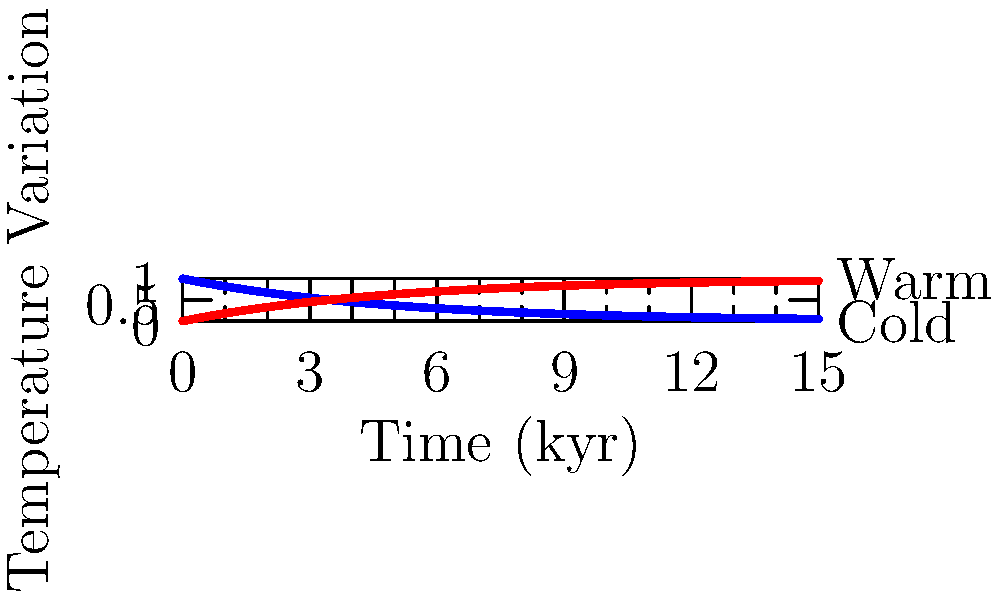In the context of using capacitor charge/discharge curves to model prehistoric climate cycles, what does the blue curve in the graph represent, and how might it relate to a specific prehistoric climate event? To answer this question, let's analyze the graph step-by-step:

1. The graph shows two curves: a blue curve (discharge) and a red curve (charge).

2. The y-axis represents temperature variation, with "Warm" at the top and "Cold" at the bottom.

3. The x-axis represents time in kiloyears (kyr).

4. The blue curve follows an exponential decay function, similar to a capacitor discharge curve: $V_C = V_0 e^{-t/\tau}$

5. In the context of prehistoric climate cycles, this curve could represent a cooling period.

6. The shape suggests a rapid initial cooling followed by a more gradual approach to the coldest point.

7. This pattern is reminiscent of the onset of an ice age or glacial period.

8. A specific prehistoric climate event that fits this pattern is the Last Glacial Maximum (LGM), which occurred around 20,000 years ago.

9. During the LGM, global temperatures dropped rapidly at first, then more slowly approached their minimum over several thousand years.

10. The time scale on the x-axis (0-15 kyr) is appropriate for modeling such long-term climate changes.

Therefore, the blue curve likely represents the cooling phase leading into an ice age, possibly modeling the temperature decline during the onset of the Last Glacial Maximum.
Answer: Cooling phase of an ice age (e.g., Last Glacial Maximum) 